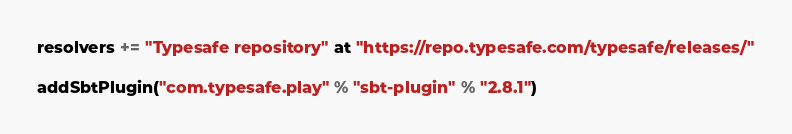<code> <loc_0><loc_0><loc_500><loc_500><_Scala_>
resolvers += "Typesafe repository" at "https://repo.typesafe.com/typesafe/releases/"

addSbtPlugin("com.typesafe.play" % "sbt-plugin" % "2.8.1")</code> 